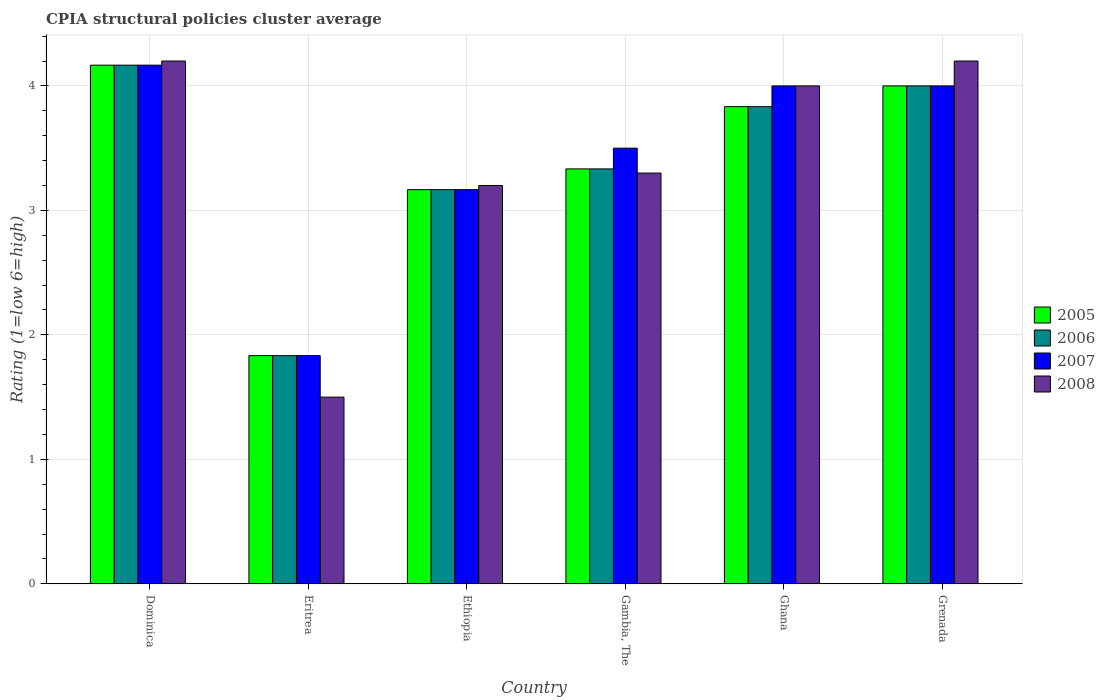How many different coloured bars are there?
Ensure brevity in your answer.  4. How many bars are there on the 5th tick from the right?
Offer a terse response. 4. What is the label of the 4th group of bars from the left?
Give a very brief answer. Gambia, The. What is the CPIA rating in 2006 in Ethiopia?
Provide a short and direct response. 3.17. Across all countries, what is the maximum CPIA rating in 2007?
Your response must be concise. 4.17. Across all countries, what is the minimum CPIA rating in 2006?
Give a very brief answer. 1.83. In which country was the CPIA rating in 2005 maximum?
Ensure brevity in your answer.  Dominica. In which country was the CPIA rating in 2005 minimum?
Keep it short and to the point. Eritrea. What is the total CPIA rating in 2005 in the graph?
Provide a short and direct response. 20.33. What is the difference between the CPIA rating in 2005 in Dominica and that in Gambia, The?
Make the answer very short. 0.83. What is the difference between the CPIA rating in 2005 in Ethiopia and the CPIA rating in 2006 in Dominica?
Offer a very short reply. -1. What is the average CPIA rating in 2007 per country?
Offer a terse response. 3.44. What is the difference between the CPIA rating of/in 2007 and CPIA rating of/in 2008 in Dominica?
Offer a terse response. -0.03. What is the ratio of the CPIA rating in 2006 in Dominica to that in Grenada?
Offer a terse response. 1.04. Is the CPIA rating in 2008 in Dominica less than that in Grenada?
Provide a short and direct response. No. Is the difference between the CPIA rating in 2007 in Eritrea and Grenada greater than the difference between the CPIA rating in 2008 in Eritrea and Grenada?
Give a very brief answer. Yes. What is the difference between the highest and the second highest CPIA rating in 2007?
Offer a very short reply. 0.17. What is the difference between the highest and the lowest CPIA rating in 2007?
Provide a succinct answer. 2.33. Is the sum of the CPIA rating in 2008 in Gambia, The and Ghana greater than the maximum CPIA rating in 2007 across all countries?
Your response must be concise. Yes. What does the 1st bar from the left in Gambia, The represents?
Provide a succinct answer. 2005. How many bars are there?
Ensure brevity in your answer.  24. How many countries are there in the graph?
Your answer should be compact. 6. Does the graph contain any zero values?
Your answer should be very brief. No. Where does the legend appear in the graph?
Your answer should be very brief. Center right. How many legend labels are there?
Give a very brief answer. 4. What is the title of the graph?
Your answer should be compact. CPIA structural policies cluster average. Does "1995" appear as one of the legend labels in the graph?
Keep it short and to the point. No. What is the label or title of the X-axis?
Ensure brevity in your answer.  Country. What is the Rating (1=low 6=high) in 2005 in Dominica?
Offer a very short reply. 4.17. What is the Rating (1=low 6=high) in 2006 in Dominica?
Your answer should be very brief. 4.17. What is the Rating (1=low 6=high) in 2007 in Dominica?
Ensure brevity in your answer.  4.17. What is the Rating (1=low 6=high) in 2008 in Dominica?
Offer a terse response. 4.2. What is the Rating (1=low 6=high) of 2005 in Eritrea?
Your response must be concise. 1.83. What is the Rating (1=low 6=high) in 2006 in Eritrea?
Give a very brief answer. 1.83. What is the Rating (1=low 6=high) of 2007 in Eritrea?
Offer a very short reply. 1.83. What is the Rating (1=low 6=high) in 2005 in Ethiopia?
Your answer should be compact. 3.17. What is the Rating (1=low 6=high) in 2006 in Ethiopia?
Make the answer very short. 3.17. What is the Rating (1=low 6=high) in 2007 in Ethiopia?
Ensure brevity in your answer.  3.17. What is the Rating (1=low 6=high) in 2005 in Gambia, The?
Provide a succinct answer. 3.33. What is the Rating (1=low 6=high) of 2006 in Gambia, The?
Offer a terse response. 3.33. What is the Rating (1=low 6=high) in 2007 in Gambia, The?
Offer a terse response. 3.5. What is the Rating (1=low 6=high) in 2008 in Gambia, The?
Provide a succinct answer. 3.3. What is the Rating (1=low 6=high) in 2005 in Ghana?
Offer a terse response. 3.83. What is the Rating (1=low 6=high) of 2006 in Ghana?
Your response must be concise. 3.83. What is the Rating (1=low 6=high) of 2006 in Grenada?
Your answer should be compact. 4. What is the Rating (1=low 6=high) of 2007 in Grenada?
Provide a succinct answer. 4. Across all countries, what is the maximum Rating (1=low 6=high) in 2005?
Your response must be concise. 4.17. Across all countries, what is the maximum Rating (1=low 6=high) in 2006?
Provide a short and direct response. 4.17. Across all countries, what is the maximum Rating (1=low 6=high) of 2007?
Ensure brevity in your answer.  4.17. Across all countries, what is the maximum Rating (1=low 6=high) in 2008?
Your response must be concise. 4.2. Across all countries, what is the minimum Rating (1=low 6=high) of 2005?
Keep it short and to the point. 1.83. Across all countries, what is the minimum Rating (1=low 6=high) in 2006?
Ensure brevity in your answer.  1.83. Across all countries, what is the minimum Rating (1=low 6=high) of 2007?
Ensure brevity in your answer.  1.83. Across all countries, what is the minimum Rating (1=low 6=high) of 2008?
Give a very brief answer. 1.5. What is the total Rating (1=low 6=high) in 2005 in the graph?
Your response must be concise. 20.33. What is the total Rating (1=low 6=high) of 2006 in the graph?
Keep it short and to the point. 20.33. What is the total Rating (1=low 6=high) in 2007 in the graph?
Offer a terse response. 20.67. What is the total Rating (1=low 6=high) in 2008 in the graph?
Offer a very short reply. 20.4. What is the difference between the Rating (1=low 6=high) in 2005 in Dominica and that in Eritrea?
Keep it short and to the point. 2.33. What is the difference between the Rating (1=low 6=high) in 2006 in Dominica and that in Eritrea?
Provide a short and direct response. 2.33. What is the difference between the Rating (1=low 6=high) in 2007 in Dominica and that in Eritrea?
Offer a very short reply. 2.33. What is the difference between the Rating (1=low 6=high) in 2008 in Dominica and that in Eritrea?
Offer a very short reply. 2.7. What is the difference between the Rating (1=low 6=high) in 2007 in Dominica and that in Ethiopia?
Provide a succinct answer. 1. What is the difference between the Rating (1=low 6=high) in 2005 in Dominica and that in Gambia, The?
Keep it short and to the point. 0.83. What is the difference between the Rating (1=low 6=high) in 2006 in Dominica and that in Ghana?
Your response must be concise. 0.33. What is the difference between the Rating (1=low 6=high) in 2005 in Dominica and that in Grenada?
Your answer should be very brief. 0.17. What is the difference between the Rating (1=low 6=high) in 2006 in Dominica and that in Grenada?
Provide a succinct answer. 0.17. What is the difference between the Rating (1=low 6=high) in 2008 in Dominica and that in Grenada?
Your answer should be very brief. 0. What is the difference between the Rating (1=low 6=high) of 2005 in Eritrea and that in Ethiopia?
Ensure brevity in your answer.  -1.33. What is the difference between the Rating (1=low 6=high) in 2006 in Eritrea and that in Ethiopia?
Keep it short and to the point. -1.33. What is the difference between the Rating (1=low 6=high) in 2007 in Eritrea and that in Ethiopia?
Your answer should be compact. -1.33. What is the difference between the Rating (1=low 6=high) of 2006 in Eritrea and that in Gambia, The?
Offer a terse response. -1.5. What is the difference between the Rating (1=low 6=high) in 2007 in Eritrea and that in Gambia, The?
Provide a short and direct response. -1.67. What is the difference between the Rating (1=low 6=high) of 2008 in Eritrea and that in Gambia, The?
Ensure brevity in your answer.  -1.8. What is the difference between the Rating (1=low 6=high) of 2007 in Eritrea and that in Ghana?
Your answer should be compact. -2.17. What is the difference between the Rating (1=low 6=high) in 2008 in Eritrea and that in Ghana?
Your response must be concise. -2.5. What is the difference between the Rating (1=low 6=high) of 2005 in Eritrea and that in Grenada?
Provide a short and direct response. -2.17. What is the difference between the Rating (1=low 6=high) of 2006 in Eritrea and that in Grenada?
Give a very brief answer. -2.17. What is the difference between the Rating (1=low 6=high) in 2007 in Eritrea and that in Grenada?
Give a very brief answer. -2.17. What is the difference between the Rating (1=low 6=high) of 2005 in Ethiopia and that in Gambia, The?
Your answer should be very brief. -0.17. What is the difference between the Rating (1=low 6=high) of 2007 in Ethiopia and that in Gambia, The?
Offer a very short reply. -0.33. What is the difference between the Rating (1=low 6=high) in 2006 in Ethiopia and that in Ghana?
Make the answer very short. -0.67. What is the difference between the Rating (1=low 6=high) in 2007 in Ethiopia and that in Ghana?
Provide a succinct answer. -0.83. What is the difference between the Rating (1=low 6=high) in 2008 in Ethiopia and that in Ghana?
Provide a succinct answer. -0.8. What is the difference between the Rating (1=low 6=high) in 2005 in Ethiopia and that in Grenada?
Ensure brevity in your answer.  -0.83. What is the difference between the Rating (1=low 6=high) in 2007 in Ethiopia and that in Grenada?
Offer a terse response. -0.83. What is the difference between the Rating (1=low 6=high) of 2006 in Gambia, The and that in Ghana?
Offer a very short reply. -0.5. What is the difference between the Rating (1=low 6=high) of 2005 in Gambia, The and that in Grenada?
Give a very brief answer. -0.67. What is the difference between the Rating (1=low 6=high) in 2007 in Gambia, The and that in Grenada?
Offer a very short reply. -0.5. What is the difference between the Rating (1=low 6=high) of 2008 in Gambia, The and that in Grenada?
Provide a succinct answer. -0.9. What is the difference between the Rating (1=low 6=high) of 2006 in Ghana and that in Grenada?
Your answer should be very brief. -0.17. What is the difference between the Rating (1=low 6=high) in 2008 in Ghana and that in Grenada?
Provide a succinct answer. -0.2. What is the difference between the Rating (1=low 6=high) in 2005 in Dominica and the Rating (1=low 6=high) in 2006 in Eritrea?
Ensure brevity in your answer.  2.33. What is the difference between the Rating (1=low 6=high) of 2005 in Dominica and the Rating (1=low 6=high) of 2007 in Eritrea?
Make the answer very short. 2.33. What is the difference between the Rating (1=low 6=high) in 2005 in Dominica and the Rating (1=low 6=high) in 2008 in Eritrea?
Your response must be concise. 2.67. What is the difference between the Rating (1=low 6=high) in 2006 in Dominica and the Rating (1=low 6=high) in 2007 in Eritrea?
Keep it short and to the point. 2.33. What is the difference between the Rating (1=low 6=high) in 2006 in Dominica and the Rating (1=low 6=high) in 2008 in Eritrea?
Make the answer very short. 2.67. What is the difference between the Rating (1=low 6=high) in 2007 in Dominica and the Rating (1=low 6=high) in 2008 in Eritrea?
Offer a very short reply. 2.67. What is the difference between the Rating (1=low 6=high) of 2005 in Dominica and the Rating (1=low 6=high) of 2006 in Ethiopia?
Ensure brevity in your answer.  1. What is the difference between the Rating (1=low 6=high) in 2005 in Dominica and the Rating (1=low 6=high) in 2008 in Ethiopia?
Provide a succinct answer. 0.97. What is the difference between the Rating (1=low 6=high) of 2006 in Dominica and the Rating (1=low 6=high) of 2008 in Ethiopia?
Provide a succinct answer. 0.97. What is the difference between the Rating (1=low 6=high) in 2007 in Dominica and the Rating (1=low 6=high) in 2008 in Ethiopia?
Give a very brief answer. 0.97. What is the difference between the Rating (1=low 6=high) in 2005 in Dominica and the Rating (1=low 6=high) in 2006 in Gambia, The?
Offer a terse response. 0.83. What is the difference between the Rating (1=low 6=high) of 2005 in Dominica and the Rating (1=low 6=high) of 2008 in Gambia, The?
Your response must be concise. 0.87. What is the difference between the Rating (1=low 6=high) in 2006 in Dominica and the Rating (1=low 6=high) in 2008 in Gambia, The?
Ensure brevity in your answer.  0.87. What is the difference between the Rating (1=low 6=high) of 2007 in Dominica and the Rating (1=low 6=high) of 2008 in Gambia, The?
Give a very brief answer. 0.87. What is the difference between the Rating (1=low 6=high) of 2006 in Dominica and the Rating (1=low 6=high) of 2007 in Ghana?
Ensure brevity in your answer.  0.17. What is the difference between the Rating (1=low 6=high) of 2007 in Dominica and the Rating (1=low 6=high) of 2008 in Ghana?
Your response must be concise. 0.17. What is the difference between the Rating (1=low 6=high) in 2005 in Dominica and the Rating (1=low 6=high) in 2007 in Grenada?
Keep it short and to the point. 0.17. What is the difference between the Rating (1=low 6=high) in 2005 in Dominica and the Rating (1=low 6=high) in 2008 in Grenada?
Ensure brevity in your answer.  -0.03. What is the difference between the Rating (1=low 6=high) in 2006 in Dominica and the Rating (1=low 6=high) in 2008 in Grenada?
Keep it short and to the point. -0.03. What is the difference between the Rating (1=low 6=high) in 2007 in Dominica and the Rating (1=low 6=high) in 2008 in Grenada?
Ensure brevity in your answer.  -0.03. What is the difference between the Rating (1=low 6=high) in 2005 in Eritrea and the Rating (1=low 6=high) in 2006 in Ethiopia?
Provide a short and direct response. -1.33. What is the difference between the Rating (1=low 6=high) in 2005 in Eritrea and the Rating (1=low 6=high) in 2007 in Ethiopia?
Provide a succinct answer. -1.33. What is the difference between the Rating (1=low 6=high) of 2005 in Eritrea and the Rating (1=low 6=high) of 2008 in Ethiopia?
Offer a very short reply. -1.37. What is the difference between the Rating (1=low 6=high) in 2006 in Eritrea and the Rating (1=low 6=high) in 2007 in Ethiopia?
Make the answer very short. -1.33. What is the difference between the Rating (1=low 6=high) of 2006 in Eritrea and the Rating (1=low 6=high) of 2008 in Ethiopia?
Your response must be concise. -1.37. What is the difference between the Rating (1=low 6=high) in 2007 in Eritrea and the Rating (1=low 6=high) in 2008 in Ethiopia?
Ensure brevity in your answer.  -1.37. What is the difference between the Rating (1=low 6=high) of 2005 in Eritrea and the Rating (1=low 6=high) of 2006 in Gambia, The?
Your answer should be compact. -1.5. What is the difference between the Rating (1=low 6=high) of 2005 in Eritrea and the Rating (1=low 6=high) of 2007 in Gambia, The?
Your answer should be compact. -1.67. What is the difference between the Rating (1=low 6=high) of 2005 in Eritrea and the Rating (1=low 6=high) of 2008 in Gambia, The?
Ensure brevity in your answer.  -1.47. What is the difference between the Rating (1=low 6=high) of 2006 in Eritrea and the Rating (1=low 6=high) of 2007 in Gambia, The?
Offer a terse response. -1.67. What is the difference between the Rating (1=low 6=high) of 2006 in Eritrea and the Rating (1=low 6=high) of 2008 in Gambia, The?
Your answer should be compact. -1.47. What is the difference between the Rating (1=low 6=high) in 2007 in Eritrea and the Rating (1=low 6=high) in 2008 in Gambia, The?
Provide a succinct answer. -1.47. What is the difference between the Rating (1=low 6=high) of 2005 in Eritrea and the Rating (1=low 6=high) of 2007 in Ghana?
Your response must be concise. -2.17. What is the difference between the Rating (1=low 6=high) in 2005 in Eritrea and the Rating (1=low 6=high) in 2008 in Ghana?
Offer a terse response. -2.17. What is the difference between the Rating (1=low 6=high) of 2006 in Eritrea and the Rating (1=low 6=high) of 2007 in Ghana?
Keep it short and to the point. -2.17. What is the difference between the Rating (1=low 6=high) of 2006 in Eritrea and the Rating (1=low 6=high) of 2008 in Ghana?
Your answer should be compact. -2.17. What is the difference between the Rating (1=low 6=high) in 2007 in Eritrea and the Rating (1=low 6=high) in 2008 in Ghana?
Ensure brevity in your answer.  -2.17. What is the difference between the Rating (1=low 6=high) in 2005 in Eritrea and the Rating (1=low 6=high) in 2006 in Grenada?
Your answer should be very brief. -2.17. What is the difference between the Rating (1=low 6=high) in 2005 in Eritrea and the Rating (1=low 6=high) in 2007 in Grenada?
Offer a very short reply. -2.17. What is the difference between the Rating (1=low 6=high) in 2005 in Eritrea and the Rating (1=low 6=high) in 2008 in Grenada?
Provide a succinct answer. -2.37. What is the difference between the Rating (1=low 6=high) of 2006 in Eritrea and the Rating (1=low 6=high) of 2007 in Grenada?
Your answer should be compact. -2.17. What is the difference between the Rating (1=low 6=high) of 2006 in Eritrea and the Rating (1=low 6=high) of 2008 in Grenada?
Make the answer very short. -2.37. What is the difference between the Rating (1=low 6=high) of 2007 in Eritrea and the Rating (1=low 6=high) of 2008 in Grenada?
Your answer should be compact. -2.37. What is the difference between the Rating (1=low 6=high) of 2005 in Ethiopia and the Rating (1=low 6=high) of 2008 in Gambia, The?
Make the answer very short. -0.13. What is the difference between the Rating (1=low 6=high) of 2006 in Ethiopia and the Rating (1=low 6=high) of 2007 in Gambia, The?
Your answer should be compact. -0.33. What is the difference between the Rating (1=low 6=high) of 2006 in Ethiopia and the Rating (1=low 6=high) of 2008 in Gambia, The?
Your answer should be compact. -0.13. What is the difference between the Rating (1=low 6=high) in 2007 in Ethiopia and the Rating (1=low 6=high) in 2008 in Gambia, The?
Give a very brief answer. -0.13. What is the difference between the Rating (1=low 6=high) in 2005 in Ethiopia and the Rating (1=low 6=high) in 2006 in Ghana?
Provide a succinct answer. -0.67. What is the difference between the Rating (1=low 6=high) in 2005 in Ethiopia and the Rating (1=low 6=high) in 2007 in Ghana?
Your answer should be very brief. -0.83. What is the difference between the Rating (1=low 6=high) of 2006 in Ethiopia and the Rating (1=low 6=high) of 2007 in Ghana?
Offer a terse response. -0.83. What is the difference between the Rating (1=low 6=high) of 2005 in Ethiopia and the Rating (1=low 6=high) of 2008 in Grenada?
Provide a succinct answer. -1.03. What is the difference between the Rating (1=low 6=high) in 2006 in Ethiopia and the Rating (1=low 6=high) in 2007 in Grenada?
Give a very brief answer. -0.83. What is the difference between the Rating (1=low 6=high) of 2006 in Ethiopia and the Rating (1=low 6=high) of 2008 in Grenada?
Give a very brief answer. -1.03. What is the difference between the Rating (1=low 6=high) in 2007 in Ethiopia and the Rating (1=low 6=high) in 2008 in Grenada?
Give a very brief answer. -1.03. What is the difference between the Rating (1=low 6=high) in 2005 in Gambia, The and the Rating (1=low 6=high) in 2007 in Ghana?
Offer a very short reply. -0.67. What is the difference between the Rating (1=low 6=high) of 2005 in Gambia, The and the Rating (1=low 6=high) of 2008 in Ghana?
Keep it short and to the point. -0.67. What is the difference between the Rating (1=low 6=high) of 2006 in Gambia, The and the Rating (1=low 6=high) of 2007 in Ghana?
Ensure brevity in your answer.  -0.67. What is the difference between the Rating (1=low 6=high) in 2007 in Gambia, The and the Rating (1=low 6=high) in 2008 in Ghana?
Keep it short and to the point. -0.5. What is the difference between the Rating (1=low 6=high) in 2005 in Gambia, The and the Rating (1=low 6=high) in 2008 in Grenada?
Offer a very short reply. -0.87. What is the difference between the Rating (1=low 6=high) in 2006 in Gambia, The and the Rating (1=low 6=high) in 2008 in Grenada?
Provide a short and direct response. -0.87. What is the difference between the Rating (1=low 6=high) in 2005 in Ghana and the Rating (1=low 6=high) in 2007 in Grenada?
Offer a terse response. -0.17. What is the difference between the Rating (1=low 6=high) of 2005 in Ghana and the Rating (1=low 6=high) of 2008 in Grenada?
Your answer should be compact. -0.37. What is the difference between the Rating (1=low 6=high) of 2006 in Ghana and the Rating (1=low 6=high) of 2007 in Grenada?
Your answer should be compact. -0.17. What is the difference between the Rating (1=low 6=high) of 2006 in Ghana and the Rating (1=low 6=high) of 2008 in Grenada?
Offer a terse response. -0.37. What is the average Rating (1=low 6=high) of 2005 per country?
Make the answer very short. 3.39. What is the average Rating (1=low 6=high) in 2006 per country?
Your answer should be very brief. 3.39. What is the average Rating (1=low 6=high) of 2007 per country?
Provide a succinct answer. 3.44. What is the average Rating (1=low 6=high) in 2008 per country?
Provide a succinct answer. 3.4. What is the difference between the Rating (1=low 6=high) of 2005 and Rating (1=low 6=high) of 2007 in Dominica?
Give a very brief answer. 0. What is the difference between the Rating (1=low 6=high) of 2005 and Rating (1=low 6=high) of 2008 in Dominica?
Your response must be concise. -0.03. What is the difference between the Rating (1=low 6=high) in 2006 and Rating (1=low 6=high) in 2007 in Dominica?
Make the answer very short. 0. What is the difference between the Rating (1=low 6=high) in 2006 and Rating (1=low 6=high) in 2008 in Dominica?
Provide a short and direct response. -0.03. What is the difference between the Rating (1=low 6=high) of 2007 and Rating (1=low 6=high) of 2008 in Dominica?
Provide a short and direct response. -0.03. What is the difference between the Rating (1=low 6=high) of 2005 and Rating (1=low 6=high) of 2006 in Eritrea?
Your response must be concise. 0. What is the difference between the Rating (1=low 6=high) of 2006 and Rating (1=low 6=high) of 2008 in Eritrea?
Offer a terse response. 0.33. What is the difference between the Rating (1=low 6=high) of 2007 and Rating (1=low 6=high) of 2008 in Eritrea?
Ensure brevity in your answer.  0.33. What is the difference between the Rating (1=low 6=high) in 2005 and Rating (1=low 6=high) in 2007 in Ethiopia?
Offer a terse response. 0. What is the difference between the Rating (1=low 6=high) of 2005 and Rating (1=low 6=high) of 2008 in Ethiopia?
Your answer should be very brief. -0.03. What is the difference between the Rating (1=low 6=high) in 2006 and Rating (1=low 6=high) in 2008 in Ethiopia?
Keep it short and to the point. -0.03. What is the difference between the Rating (1=low 6=high) of 2007 and Rating (1=low 6=high) of 2008 in Ethiopia?
Provide a succinct answer. -0.03. What is the difference between the Rating (1=low 6=high) in 2006 and Rating (1=low 6=high) in 2008 in Gambia, The?
Offer a terse response. 0.03. What is the difference between the Rating (1=low 6=high) in 2007 and Rating (1=low 6=high) in 2008 in Gambia, The?
Provide a succinct answer. 0.2. What is the difference between the Rating (1=low 6=high) in 2005 and Rating (1=low 6=high) in 2006 in Ghana?
Provide a succinct answer. 0. What is the difference between the Rating (1=low 6=high) of 2005 and Rating (1=low 6=high) of 2007 in Ghana?
Offer a very short reply. -0.17. What is the difference between the Rating (1=low 6=high) of 2006 and Rating (1=low 6=high) of 2007 in Ghana?
Your answer should be compact. -0.17. What is the difference between the Rating (1=low 6=high) of 2007 and Rating (1=low 6=high) of 2008 in Ghana?
Keep it short and to the point. 0. What is the difference between the Rating (1=low 6=high) in 2005 and Rating (1=low 6=high) in 2006 in Grenada?
Give a very brief answer. 0. What is the difference between the Rating (1=low 6=high) in 2005 and Rating (1=low 6=high) in 2008 in Grenada?
Give a very brief answer. -0.2. What is the difference between the Rating (1=low 6=high) of 2006 and Rating (1=low 6=high) of 2007 in Grenada?
Offer a very short reply. 0. What is the difference between the Rating (1=low 6=high) of 2006 and Rating (1=low 6=high) of 2008 in Grenada?
Your answer should be very brief. -0.2. What is the ratio of the Rating (1=low 6=high) of 2005 in Dominica to that in Eritrea?
Keep it short and to the point. 2.27. What is the ratio of the Rating (1=low 6=high) in 2006 in Dominica to that in Eritrea?
Provide a succinct answer. 2.27. What is the ratio of the Rating (1=low 6=high) of 2007 in Dominica to that in Eritrea?
Provide a short and direct response. 2.27. What is the ratio of the Rating (1=low 6=high) in 2008 in Dominica to that in Eritrea?
Your response must be concise. 2.8. What is the ratio of the Rating (1=low 6=high) in 2005 in Dominica to that in Ethiopia?
Offer a terse response. 1.32. What is the ratio of the Rating (1=low 6=high) of 2006 in Dominica to that in Ethiopia?
Your answer should be compact. 1.32. What is the ratio of the Rating (1=low 6=high) of 2007 in Dominica to that in Ethiopia?
Offer a terse response. 1.32. What is the ratio of the Rating (1=low 6=high) of 2008 in Dominica to that in Ethiopia?
Your response must be concise. 1.31. What is the ratio of the Rating (1=low 6=high) in 2007 in Dominica to that in Gambia, The?
Your answer should be very brief. 1.19. What is the ratio of the Rating (1=low 6=high) in 2008 in Dominica to that in Gambia, The?
Offer a terse response. 1.27. What is the ratio of the Rating (1=low 6=high) of 2005 in Dominica to that in Ghana?
Give a very brief answer. 1.09. What is the ratio of the Rating (1=low 6=high) of 2006 in Dominica to that in Ghana?
Provide a succinct answer. 1.09. What is the ratio of the Rating (1=low 6=high) of 2007 in Dominica to that in Ghana?
Your answer should be very brief. 1.04. What is the ratio of the Rating (1=low 6=high) in 2005 in Dominica to that in Grenada?
Provide a short and direct response. 1.04. What is the ratio of the Rating (1=low 6=high) in 2006 in Dominica to that in Grenada?
Provide a succinct answer. 1.04. What is the ratio of the Rating (1=low 6=high) of 2007 in Dominica to that in Grenada?
Provide a succinct answer. 1.04. What is the ratio of the Rating (1=low 6=high) in 2008 in Dominica to that in Grenada?
Keep it short and to the point. 1. What is the ratio of the Rating (1=low 6=high) of 2005 in Eritrea to that in Ethiopia?
Your answer should be compact. 0.58. What is the ratio of the Rating (1=low 6=high) in 2006 in Eritrea to that in Ethiopia?
Provide a short and direct response. 0.58. What is the ratio of the Rating (1=low 6=high) of 2007 in Eritrea to that in Ethiopia?
Your answer should be compact. 0.58. What is the ratio of the Rating (1=low 6=high) of 2008 in Eritrea to that in Ethiopia?
Make the answer very short. 0.47. What is the ratio of the Rating (1=low 6=high) in 2005 in Eritrea to that in Gambia, The?
Provide a short and direct response. 0.55. What is the ratio of the Rating (1=low 6=high) of 2006 in Eritrea to that in Gambia, The?
Offer a terse response. 0.55. What is the ratio of the Rating (1=low 6=high) of 2007 in Eritrea to that in Gambia, The?
Keep it short and to the point. 0.52. What is the ratio of the Rating (1=low 6=high) of 2008 in Eritrea to that in Gambia, The?
Your answer should be very brief. 0.45. What is the ratio of the Rating (1=low 6=high) of 2005 in Eritrea to that in Ghana?
Keep it short and to the point. 0.48. What is the ratio of the Rating (1=low 6=high) of 2006 in Eritrea to that in Ghana?
Provide a succinct answer. 0.48. What is the ratio of the Rating (1=low 6=high) of 2007 in Eritrea to that in Ghana?
Your response must be concise. 0.46. What is the ratio of the Rating (1=low 6=high) in 2008 in Eritrea to that in Ghana?
Provide a short and direct response. 0.38. What is the ratio of the Rating (1=low 6=high) of 2005 in Eritrea to that in Grenada?
Your answer should be very brief. 0.46. What is the ratio of the Rating (1=low 6=high) of 2006 in Eritrea to that in Grenada?
Provide a succinct answer. 0.46. What is the ratio of the Rating (1=low 6=high) in 2007 in Eritrea to that in Grenada?
Offer a very short reply. 0.46. What is the ratio of the Rating (1=low 6=high) in 2008 in Eritrea to that in Grenada?
Keep it short and to the point. 0.36. What is the ratio of the Rating (1=low 6=high) of 2005 in Ethiopia to that in Gambia, The?
Provide a succinct answer. 0.95. What is the ratio of the Rating (1=low 6=high) in 2007 in Ethiopia to that in Gambia, The?
Make the answer very short. 0.9. What is the ratio of the Rating (1=low 6=high) of 2008 in Ethiopia to that in Gambia, The?
Ensure brevity in your answer.  0.97. What is the ratio of the Rating (1=low 6=high) in 2005 in Ethiopia to that in Ghana?
Offer a terse response. 0.83. What is the ratio of the Rating (1=low 6=high) in 2006 in Ethiopia to that in Ghana?
Offer a terse response. 0.83. What is the ratio of the Rating (1=low 6=high) of 2007 in Ethiopia to that in Ghana?
Offer a very short reply. 0.79. What is the ratio of the Rating (1=low 6=high) in 2008 in Ethiopia to that in Ghana?
Make the answer very short. 0.8. What is the ratio of the Rating (1=low 6=high) of 2005 in Ethiopia to that in Grenada?
Make the answer very short. 0.79. What is the ratio of the Rating (1=low 6=high) of 2006 in Ethiopia to that in Grenada?
Give a very brief answer. 0.79. What is the ratio of the Rating (1=low 6=high) in 2007 in Ethiopia to that in Grenada?
Provide a short and direct response. 0.79. What is the ratio of the Rating (1=low 6=high) of 2008 in Ethiopia to that in Grenada?
Keep it short and to the point. 0.76. What is the ratio of the Rating (1=low 6=high) in 2005 in Gambia, The to that in Ghana?
Provide a succinct answer. 0.87. What is the ratio of the Rating (1=low 6=high) in 2006 in Gambia, The to that in Ghana?
Your answer should be very brief. 0.87. What is the ratio of the Rating (1=low 6=high) of 2008 in Gambia, The to that in Ghana?
Make the answer very short. 0.82. What is the ratio of the Rating (1=low 6=high) of 2005 in Gambia, The to that in Grenada?
Offer a very short reply. 0.83. What is the ratio of the Rating (1=low 6=high) of 2007 in Gambia, The to that in Grenada?
Offer a terse response. 0.88. What is the ratio of the Rating (1=low 6=high) of 2008 in Gambia, The to that in Grenada?
Make the answer very short. 0.79. What is the ratio of the Rating (1=low 6=high) in 2005 in Ghana to that in Grenada?
Give a very brief answer. 0.96. What is the ratio of the Rating (1=low 6=high) of 2006 in Ghana to that in Grenada?
Keep it short and to the point. 0.96. What is the ratio of the Rating (1=low 6=high) of 2008 in Ghana to that in Grenada?
Your answer should be very brief. 0.95. What is the difference between the highest and the second highest Rating (1=low 6=high) in 2006?
Your answer should be compact. 0.17. What is the difference between the highest and the lowest Rating (1=low 6=high) of 2005?
Your answer should be very brief. 2.33. What is the difference between the highest and the lowest Rating (1=low 6=high) in 2006?
Your answer should be compact. 2.33. What is the difference between the highest and the lowest Rating (1=low 6=high) of 2007?
Your answer should be very brief. 2.33. What is the difference between the highest and the lowest Rating (1=low 6=high) of 2008?
Your answer should be very brief. 2.7. 